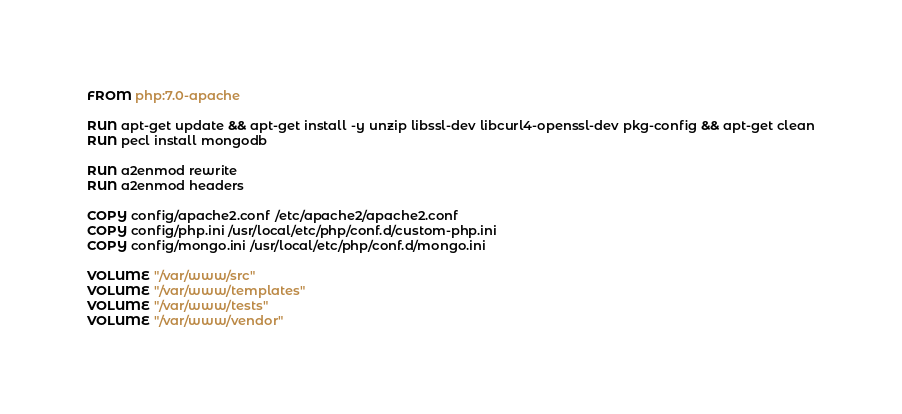<code> <loc_0><loc_0><loc_500><loc_500><_Dockerfile_>FROM php:7.0-apache

RUN apt-get update && apt-get install -y unzip libssl-dev libcurl4-openssl-dev pkg-config && apt-get clean
RUN pecl install mongodb

RUN a2enmod rewrite
RUN a2enmod headers

COPY config/apache2.conf /etc/apache2/apache2.conf
COPY config/php.ini /usr/local/etc/php/conf.d/custom-php.ini
COPY config/mongo.ini /usr/local/etc/php/conf.d/mongo.ini

VOLUME "/var/www/src"
VOLUME "/var/www/templates"
VOLUME "/var/www/tests"
VOLUME "/var/www/vendor"
</code> 